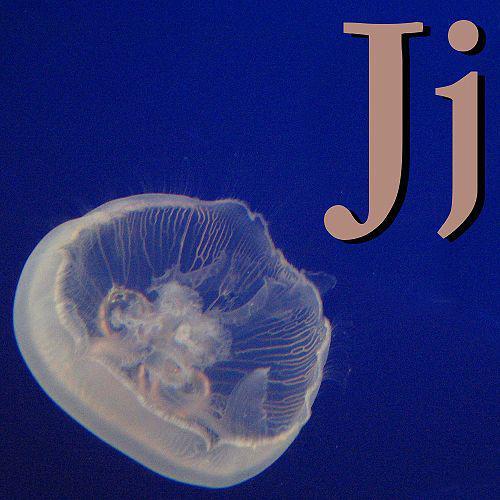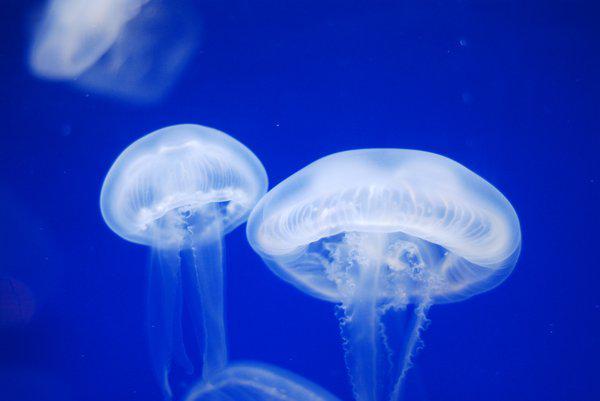The first image is the image on the left, the second image is the image on the right. Considering the images on both sides, is "there is only one jellyfish on one of the images" valid? Answer yes or no. Yes. 